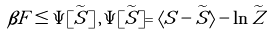<formula> <loc_0><loc_0><loc_500><loc_500>\beta F \leq \Psi [ \widetilde { S } ] \, , \, \Psi [ \widetilde { S } ] = \langle S - \widetilde { S } \rangle - \ln \widetilde { Z }</formula> 